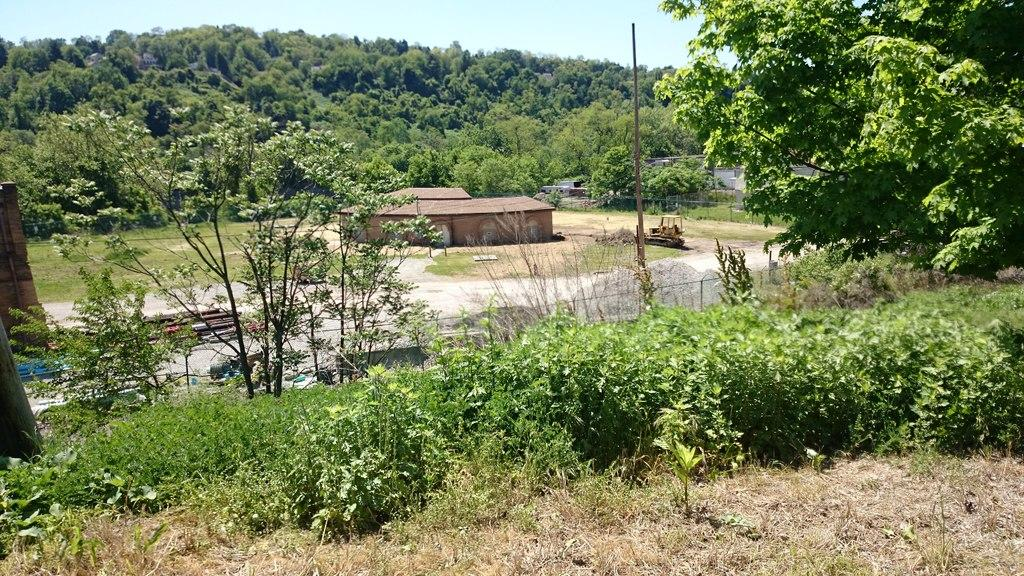What type of surface can be seen in the image? Ground is visible in the image. What type of vegetation is present in the image? There are plants and trees in the image. What type of barrier is present in the image? There is fencing in the image. What type of structure is present in the image? There are buildings in the image. What is visible in the background of the image? Trees and the sky are visible in the background of the image. What type of vegetable is being used to clean the wooden pole in the image? There is no vegetable present in the image, let alone one being used to clean the wooden pole. 